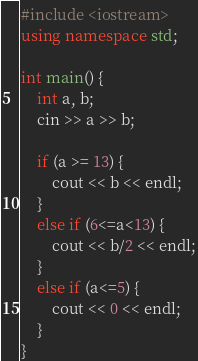Convert code to text. <code><loc_0><loc_0><loc_500><loc_500><_C++_>#include <iostream>
using namespace std;

int main() {
	int a, b;
	cin >> a >> b;

	if (a >= 13) {
		cout << b << endl;
	}
	else if (6<=a<13) {
		cout << b/2 << endl;
	}
	else if (a<=5) {
		cout << 0 << endl;
	}
}</code> 